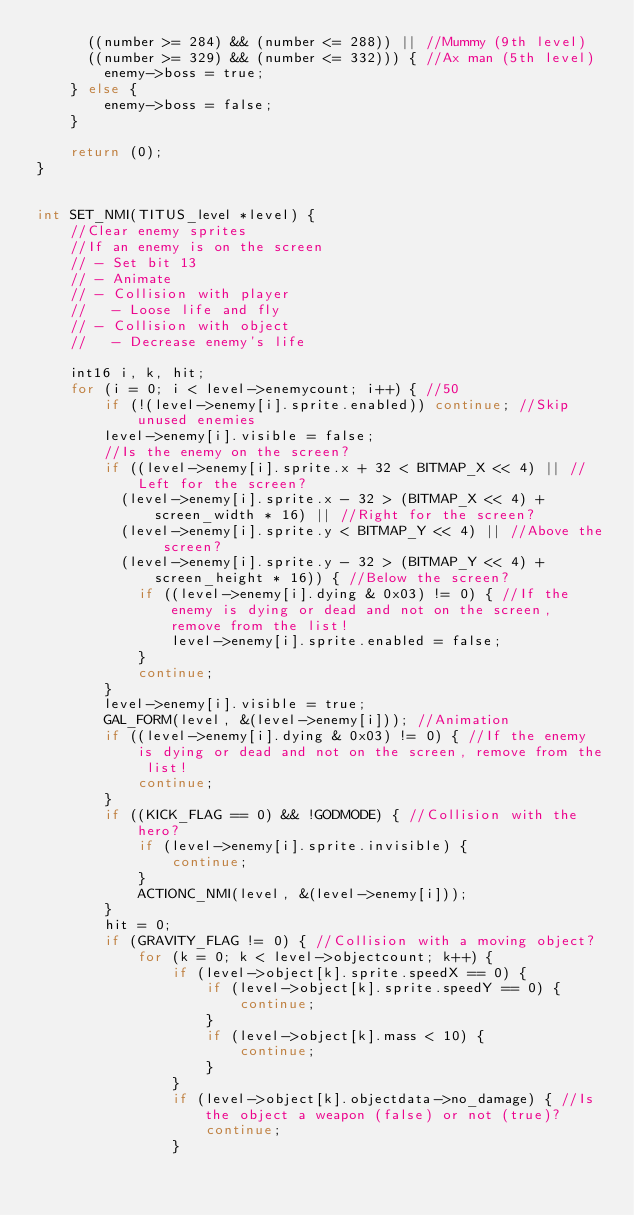Convert code to text. <code><loc_0><loc_0><loc_500><loc_500><_C_>      ((number >= 284) && (number <= 288)) || //Mummy (9th level)
      ((number >= 329) && (number <= 332))) { //Ax man (5th level)
        enemy->boss = true;
    } else {
        enemy->boss = false;
    }
    
    return (0);
}


int SET_NMI(TITUS_level *level) {
    //Clear enemy sprites
    //If an enemy is on the screen
    // - Set bit 13
    // - Animate
    // - Collision with player
    //   - Loose life and fly
    // - Collision with object
    //   - Decrease enemy's life

    int16 i, k, hit;
    for (i = 0; i < level->enemycount; i++) { //50
        if (!(level->enemy[i].sprite.enabled)) continue; //Skip unused enemies
        level->enemy[i].visible = false;
        //Is the enemy on the screen?
        if ((level->enemy[i].sprite.x + 32 < BITMAP_X << 4) || //Left for the screen?
          (level->enemy[i].sprite.x - 32 > (BITMAP_X << 4) + screen_width * 16) || //Right for the screen?
          (level->enemy[i].sprite.y < BITMAP_Y << 4) || //Above the screen?
          (level->enemy[i].sprite.y - 32 > (BITMAP_Y << 4) + screen_height * 16)) { //Below the screen?
            if ((level->enemy[i].dying & 0x03) != 0) { //If the enemy is dying or dead and not on the screen, remove from the list!
                level->enemy[i].sprite.enabled = false;
            }
            continue;
        }
        level->enemy[i].visible = true;
        GAL_FORM(level, &(level->enemy[i])); //Animation
        if ((level->enemy[i].dying & 0x03) != 0) { //If the enemy is dying or dead and not on the screen, remove from the list!
            continue;
        }
        if ((KICK_FLAG == 0) && !GODMODE) { //Collision with the hero?
            if (level->enemy[i].sprite.invisible) {
                continue;
            }
            ACTIONC_NMI(level, &(level->enemy[i]));
        }
        hit = 0;
        if (GRAVITY_FLAG != 0) { //Collision with a moving object?
            for (k = 0; k < level->objectcount; k++) {
                if (level->object[k].sprite.speedX == 0) {
                    if (level->object[k].sprite.speedY == 0) {
                        continue;
                    }
                    if (level->object[k].mass < 10) {
                        continue;
                    }
                }
                if (level->object[k].objectdata->no_damage) { //Is the object a weapon (false) or not (true)?
                    continue;
                }</code> 